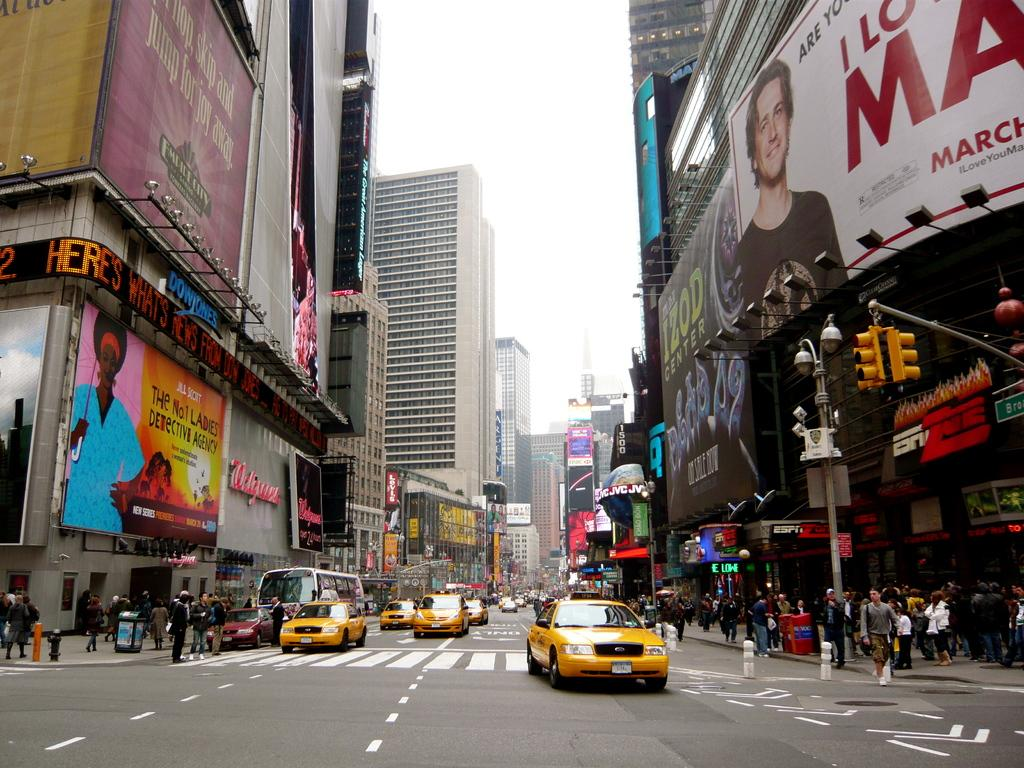<image>
Present a compact description of the photo's key features. Several taxis are driving down a busy city street past a building that says Walgreen's. 